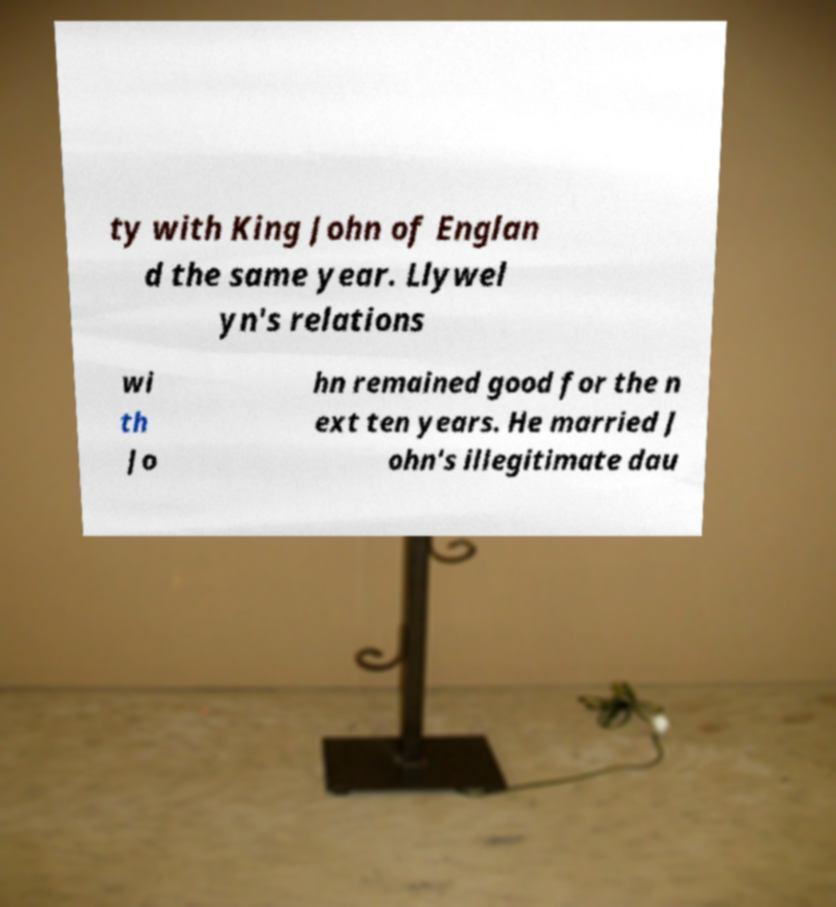What messages or text are displayed in this image? I need them in a readable, typed format. ty with King John of Englan d the same year. Llywel yn's relations wi th Jo hn remained good for the n ext ten years. He married J ohn's illegitimate dau 